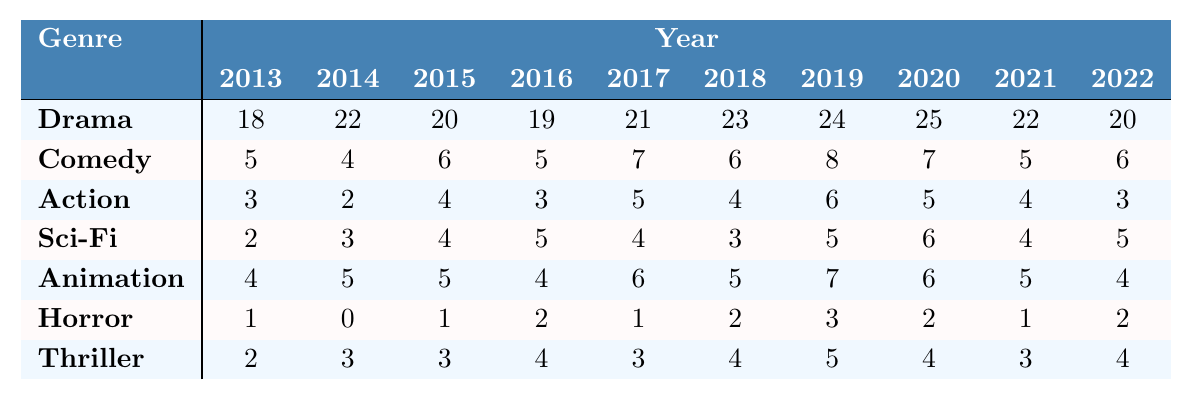What genre received the highest number of Oscar nominations in 2020? In 2020, the Drama genre had 25 nominations, which is higher than all other genres listed.
Answer: Drama Which genre consistently had the lowest number of nominations across all years? By observing the table, the Horror genre has the lowest number of nominations in several years, with a maximum of 3 in 2019 and no nominations in 2014.
Answer: Horror What is the total number of Oscar nominations for the Action genre over the last decade? The total for the Action genre can be found by adding the nominations for each year: 3 + 2 + 4 + 3 + 5 + 4 + 6 + 5 + 4 + 3 = 43.
Answer: 43 Which genre showed an increase in nominations from 2013 to 2019? If we compare the nominations from 2013 to 2019, the Drama and Animation genres both increased their nominations, specifically Drama increased from 18 to 24 and Animation from 4 to 7.
Answer: Drama and Animation What is the average number of nominations for the Sci-Fi genre over the decade? The total nominations for Sci-Fi are 2 + 3 + 4 + 5 + 4 + 3 + 5 + 6 + 4 + 5 = 43. There are 10 years, so the average is 43/10 = 4.3.
Answer: 4.3 For which genre was the peak of nominations observed and in what year? The Drama genre peaked in 2020 with 25 nominations, which is the highest number across all genres for that year.
Answer: Drama in 2020 Did Comedy or Animation have more nominations in 2017? In 2017, Animation had 6 nominations, while Comedy had 7 nominations. Therefore, Comedy had more nominations that year.
Answer: Yes, Comedy What is the difference in nominations for the Thriller genre between 2013 and 2022? In 2013, the Thriller genre had 2 nominations and in 2022 it had 4. The difference is 4 - 2 = 2.
Answer: 2 Which genre had an upward trend in nominations from 2018 to 2020? Observing the data from 2018 to 2020, the Drama genre increased from 23 to 25 nominations.
Answer: Drama How does the total number of nominations for Horror compare to that of Action across the decade? Horror had a total of 1 + 0 + 1 + 2 + 1 + 2 + 3 + 2 + 1 + 2 = 15 nominations and Action had 43 nominations. The comparison shows Horror has significantly less than Action.
Answer: Horror has less than Action 